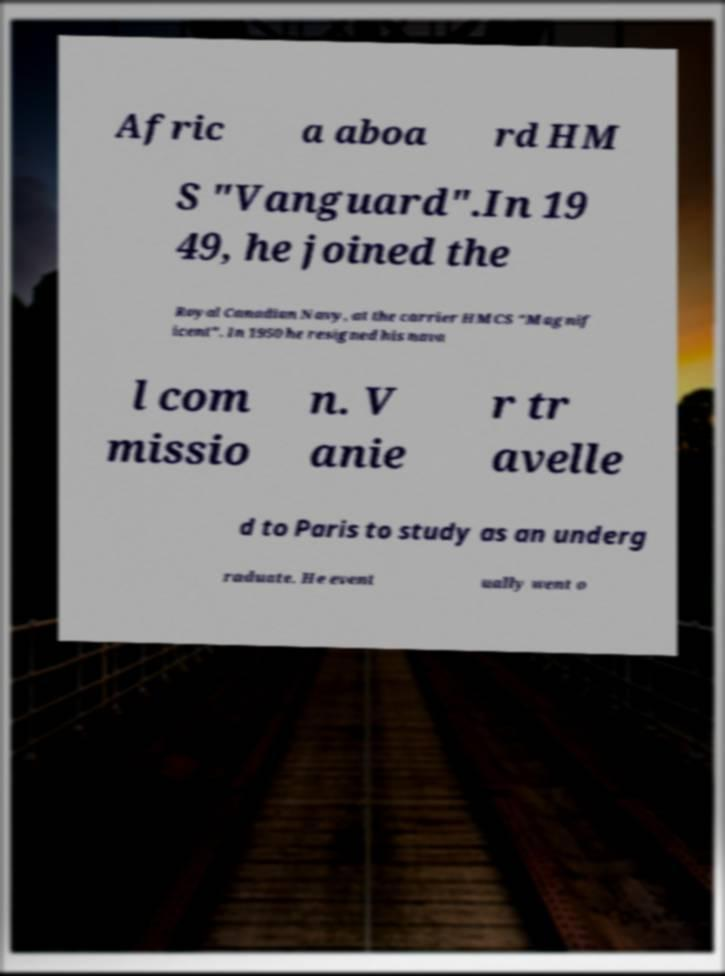I need the written content from this picture converted into text. Can you do that? Afric a aboa rd HM S "Vanguard".In 19 49, he joined the Royal Canadian Navy, at the carrier HMCS "Magnif icent". In 1950 he resigned his nava l com missio n. V anie r tr avelle d to Paris to study as an underg raduate. He event ually went o 